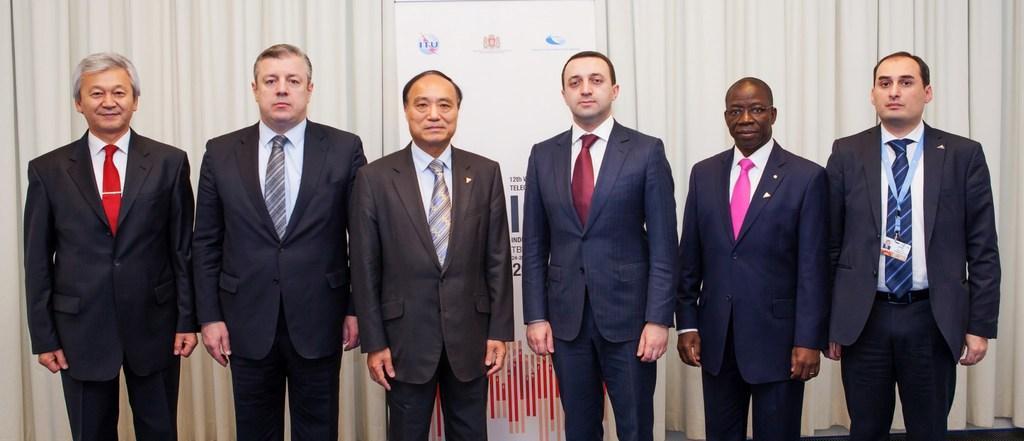Describe this image in one or two sentences. In this image I can see few men are standing and I can see all of them are wearing formal dress. On the right side of this image I can see one of them is wearing an ID card. Behind them I can see white colour curtains, a white colour board and on it I can see something is written. 